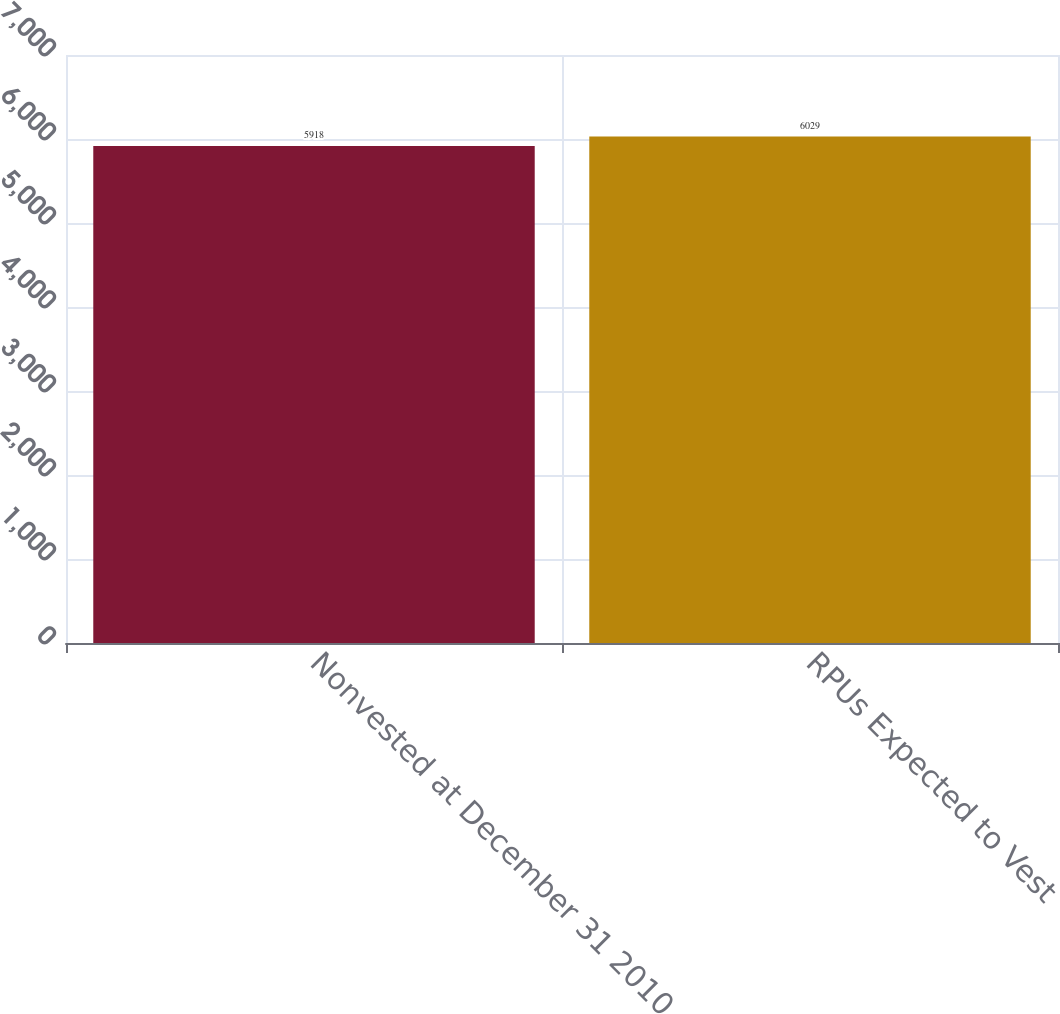Convert chart to OTSL. <chart><loc_0><loc_0><loc_500><loc_500><bar_chart><fcel>Nonvested at December 31 2010<fcel>RPUs Expected to Vest<nl><fcel>5918<fcel>6029<nl></chart> 